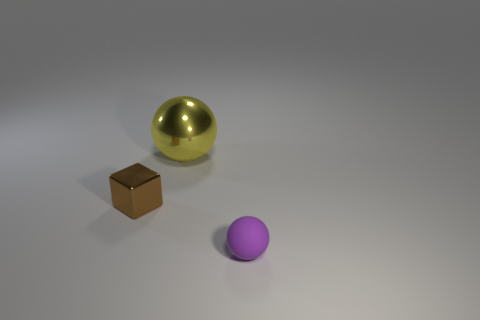Add 2 tiny metallic cylinders. How many objects exist? 5 Subtract all purple spheres. How many spheres are left? 1 Subtract all balls. How many objects are left? 1 Subtract 0 blue balls. How many objects are left? 3 Subtract all yellow cubes. Subtract all brown cylinders. How many cubes are left? 1 Subtract all big rubber spheres. Subtract all small brown metal objects. How many objects are left? 2 Add 2 big yellow metallic things. How many big yellow metallic things are left? 3 Add 1 large balls. How many large balls exist? 2 